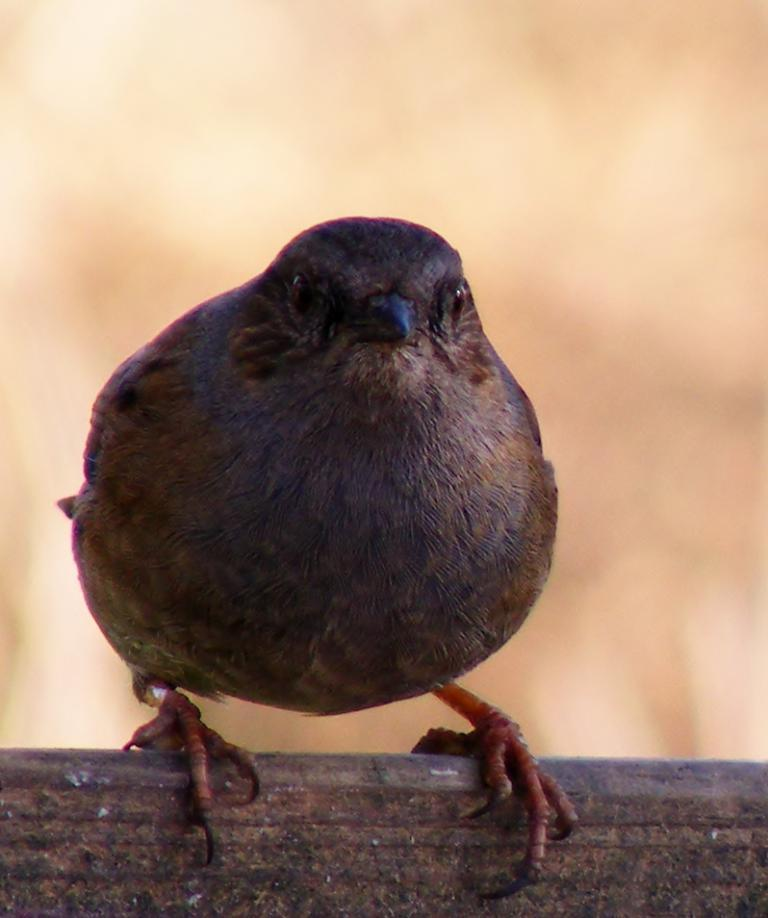What type of animal is present in the image? There is a bird in the image. Where is the bird located? The bird is on a surface that resembles a wall. Can you describe the background of the image? The background of the image is blurred. What type of meat is the bird holding in the image? There is no meat present in the image; it only features a bird on a wall with a blurred background. 